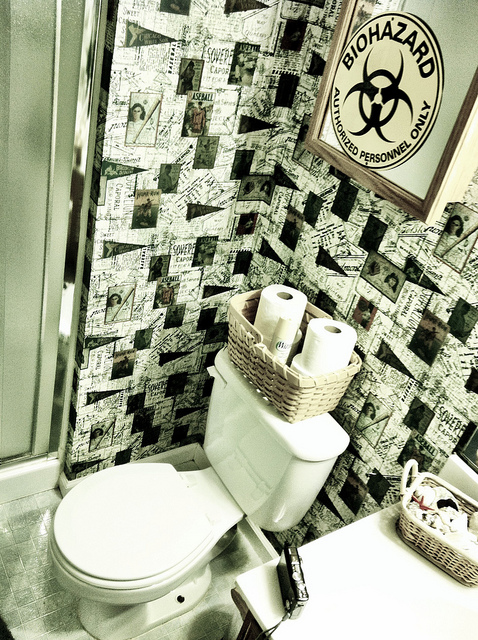Identify the text displayed in this image. SOVERS BIOHAZARD AUTHORIZED P PERSONNEL ONLY AUTHORIZED CAPORAL CAPORAL CAPORAL CAPOR ASEBALL CAPOR SOVERE CAPOR SOVERN 